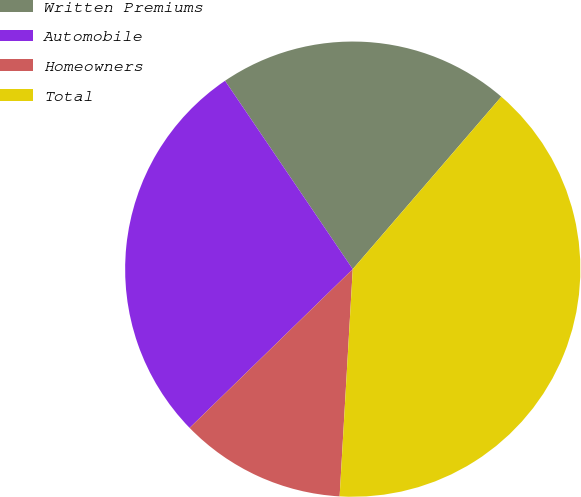<chart> <loc_0><loc_0><loc_500><loc_500><pie_chart><fcel>Written Premiums<fcel>Automobile<fcel>Homeowners<fcel>Total<nl><fcel>20.8%<fcel>27.8%<fcel>11.8%<fcel>39.6%<nl></chart> 